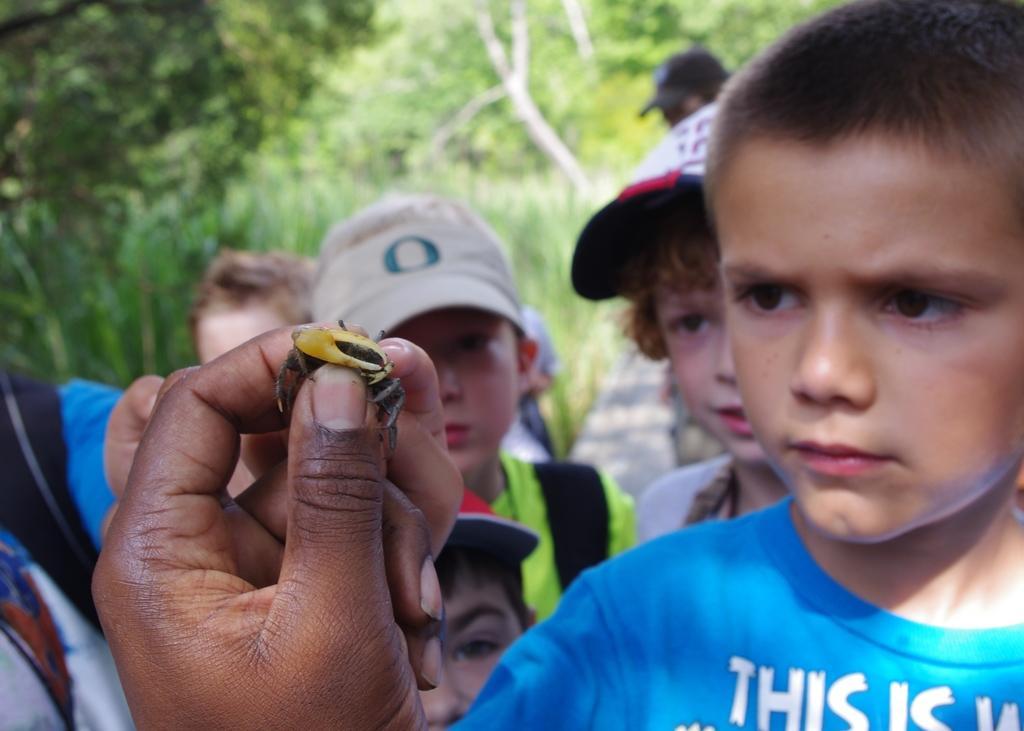Could you give a brief overview of what you see in this image? In this image, I can see a person's hand holding an insect. There are group of people. In the background, I can see the trees. 